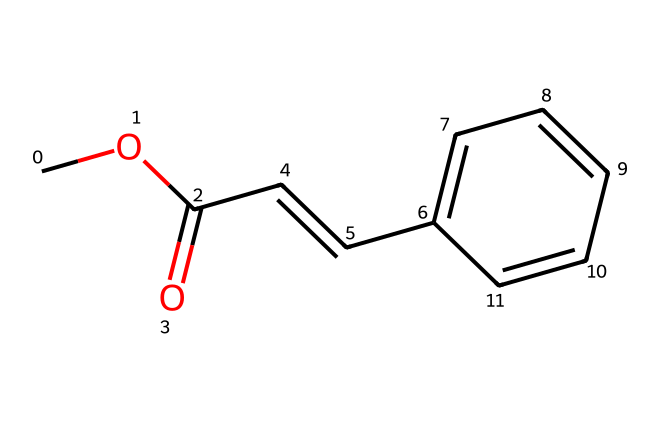How many carbon atoms are present in this chemical? Counting the carbon (C) atoms in the given SMILES representation, we find: 2 in the ester group (COC=O), 1 in the double bond (C=C), and 5 in the benzene ring (C6H5). This totals 8 carbon atoms.
Answer: 8 What functional group is represented by "COC(=O)" in this chemical? The "COC(=O)" part indicates an ester functional group, where "C(=O)" is the carbonyl part and "O" is the oxygen connecting to another carbon (the alkyl chain).
Answer: ester What type of bond is represented between the carbon atoms in the structure? The bond between the carbon atoms in "C=C" indicates a double bond, while the other carbon-carbon connections are single bonds.
Answer: double Which part of the molecule contributes to its UV sensitivity? The C=C double bond and the aromatic ring (phenyl group, represented by "c1ccccc1") are known to absorb UV light, making this part the UV-sensitive section of the molecule.
Answer: C=C and aromatic ring How many hydrogen atoms are attached to the benzene ring in this chemical? The benzene ring, which consists of six carbon atoms and has alternating double bonds, generally has 5 hydrogen atoms attached (one hydrogen is replaced by the neighboring carbon in the ester).
Answer: 5 What property do cinnamate esters usually exhibit in sunscreen formulations? Cinnamate esters are known for their ability to absorb UV radiation, providing protection from sun damage, thereby acting as UV filters in sunscreen.
Answer: UV filters 